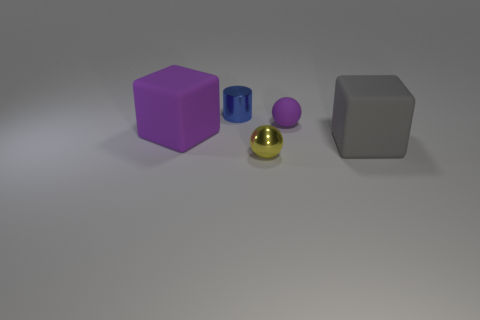Add 2 small yellow rubber things. How many objects exist? 7 Subtract all balls. How many objects are left? 3 Add 5 tiny blue shiny spheres. How many tiny blue shiny spheres exist? 5 Subtract 1 yellow spheres. How many objects are left? 4 Subtract all large red cylinders. Subtract all tiny blue objects. How many objects are left? 4 Add 3 small rubber spheres. How many small rubber spheres are left? 4 